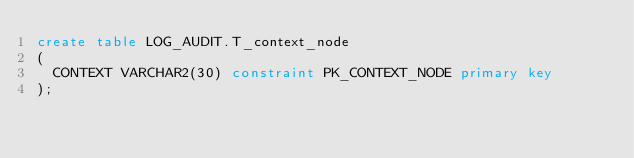Convert code to text. <code><loc_0><loc_0><loc_500><loc_500><_SQL_>create table LOG_AUDIT.T_context_node
(
  CONTEXT VARCHAR2(30) constraint PK_CONTEXT_NODE primary key 
);

</code> 